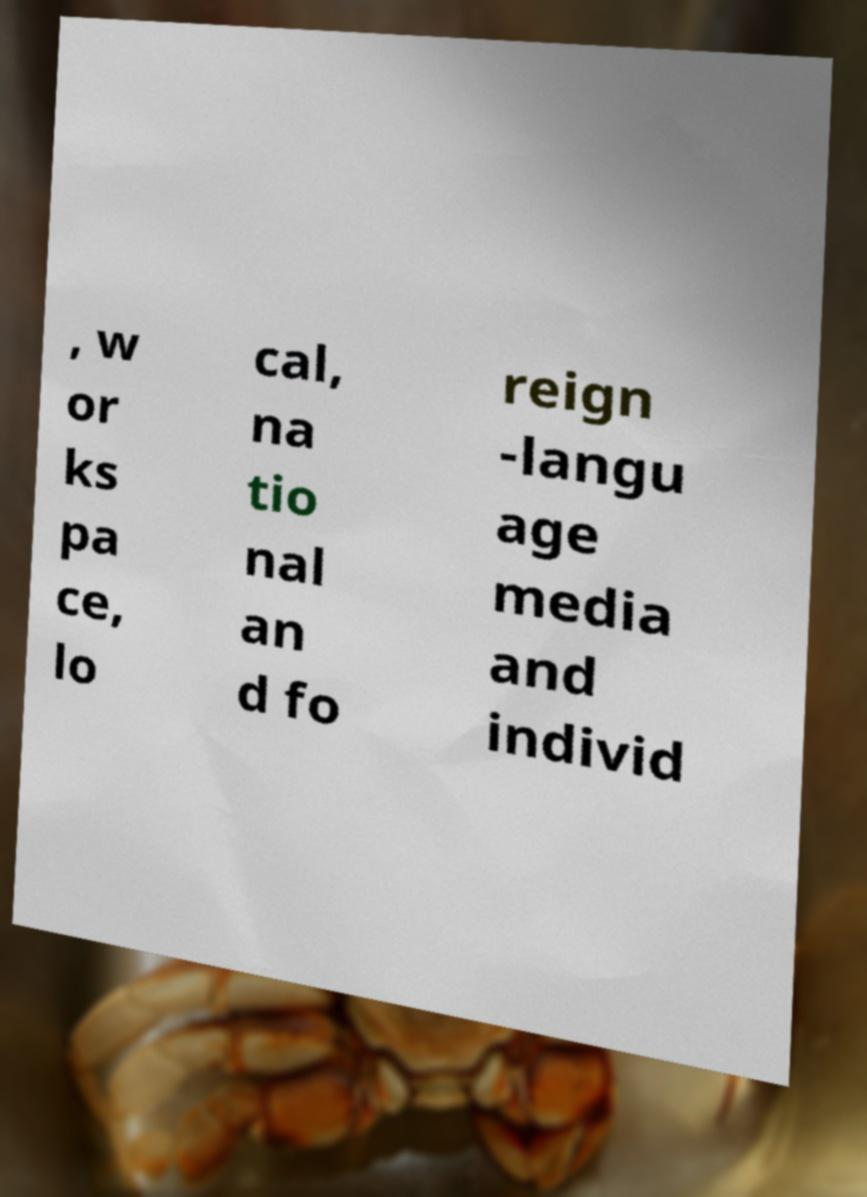Can you accurately transcribe the text from the provided image for me? , w or ks pa ce, lo cal, na tio nal an d fo reign -langu age media and individ 